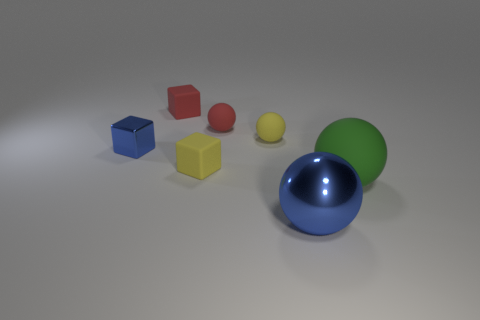Add 3 small rubber balls. How many objects exist? 10 Subtract all blocks. How many objects are left? 4 Add 7 matte blocks. How many matte blocks exist? 9 Subtract 0 cyan spheres. How many objects are left? 7 Subtract all metallic objects. Subtract all metal cubes. How many objects are left? 4 Add 7 red matte objects. How many red matte objects are left? 9 